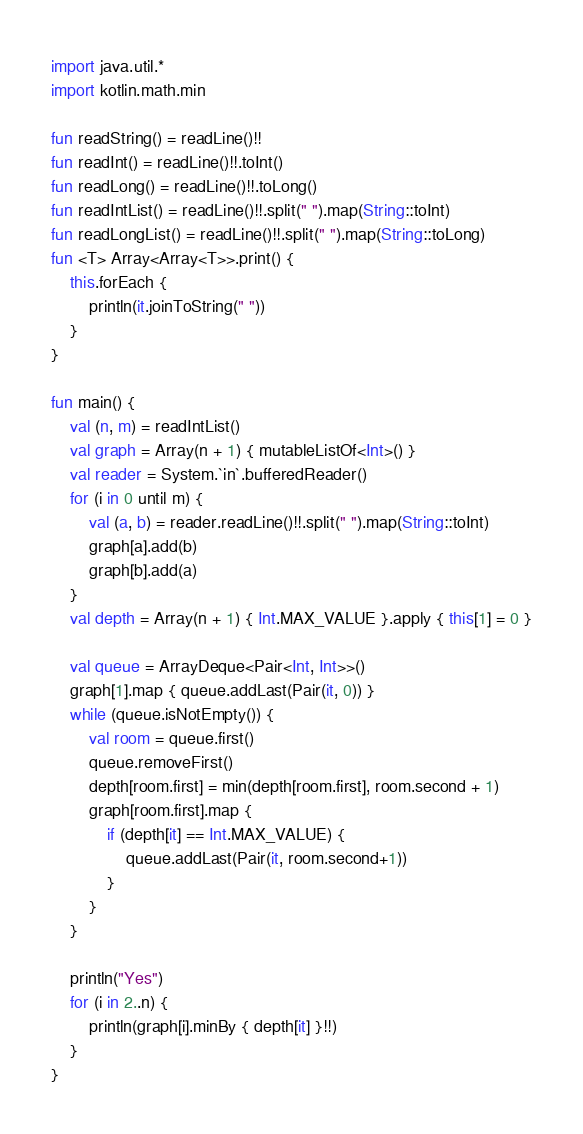Convert code to text. <code><loc_0><loc_0><loc_500><loc_500><_Kotlin_>import java.util.*
import kotlin.math.min

fun readString() = readLine()!!
fun readInt() = readLine()!!.toInt()
fun readLong() = readLine()!!.toLong()
fun readIntList() = readLine()!!.split(" ").map(String::toInt)
fun readLongList() = readLine()!!.split(" ").map(String::toLong)
fun <T> Array<Array<T>>.print() {
    this.forEach {
        println(it.joinToString(" "))
    }
}

fun main() {
    val (n, m) = readIntList()
    val graph = Array(n + 1) { mutableListOf<Int>() }
    val reader = System.`in`.bufferedReader()
    for (i in 0 until m) {
        val (a, b) = reader.readLine()!!.split(" ").map(String::toInt)
        graph[a].add(b)
        graph[b].add(a)
    }
    val depth = Array(n + 1) { Int.MAX_VALUE }.apply { this[1] = 0 }

    val queue = ArrayDeque<Pair<Int, Int>>()
    graph[1].map { queue.addLast(Pair(it, 0)) }
    while (queue.isNotEmpty()) {
        val room = queue.first()
        queue.removeFirst()
        depth[room.first] = min(depth[room.first], room.second + 1)
        graph[room.first].map {
            if (depth[it] == Int.MAX_VALUE) {
                queue.addLast(Pair(it, room.second+1))
            }
        }
    }

    println("Yes")
    for (i in 2..n) {
        println(graph[i].minBy { depth[it] }!!)
    }
}
</code> 